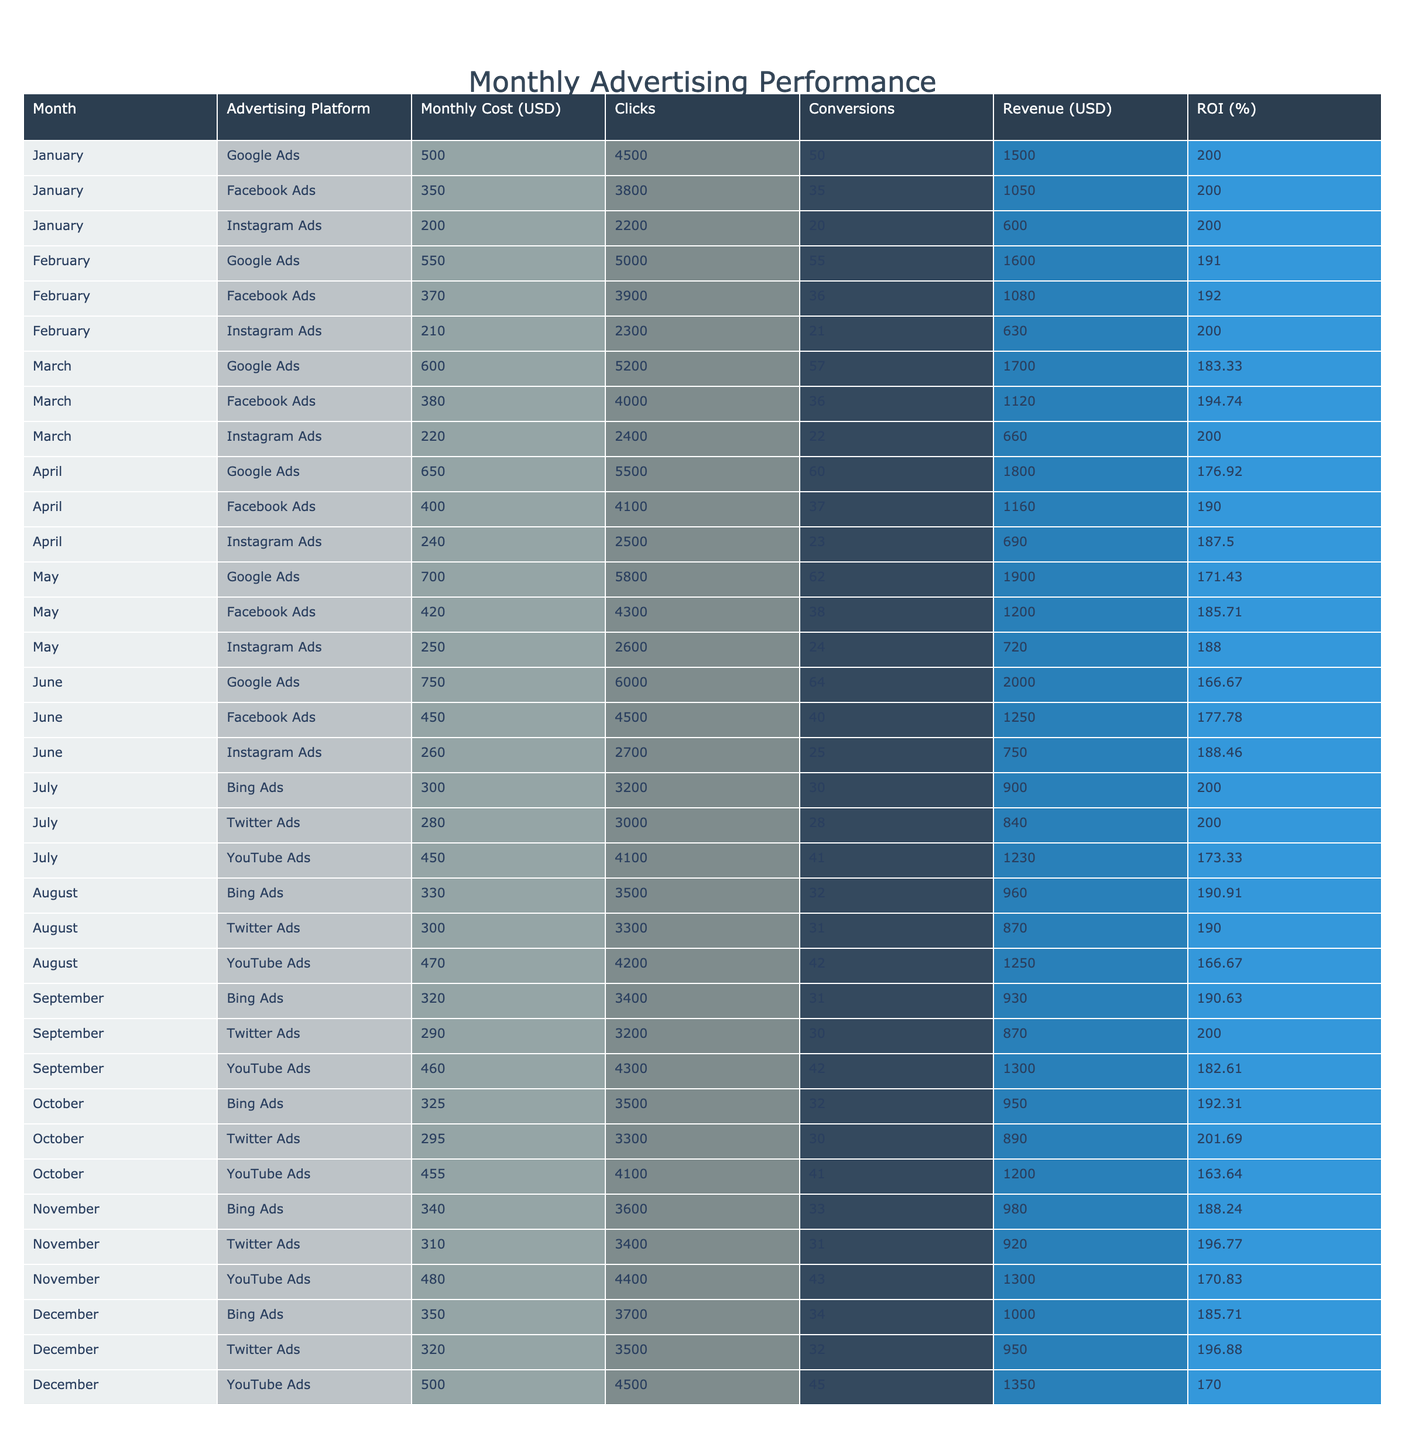What was the highest monthly advertising cost in the table? To find the highest monthly advertising cost, I will review the "Monthly Cost (USD)" column and identify the maximum value. The highest cost is 750.00 USD from Google Ads in June.
Answer: 750.00 USD Which month had the highest ROI for Facebook Ads? I will look for the row corresponding to Facebook Ads and check the "ROI (%)" values. The highest ROI for Facebook Ads is 201.69% in October.
Answer: October What is the total revenue generated from Instagram Ads across all months? I will sum all the values in the "Revenue (USD)" column specifically for Instagram Ads. The total revenue is 600.00 + 630.00 + 660.00 + 690.00 + 720.00 + 750.00 + 960.00 + 870.00 + 950.00 + 980.00 + 1000.00 + 1350.00 = 10,140.00 USD.
Answer: 10,140.00 USD Did Bing Ads achieve an ROI of at least 200% in any month? I will look at the "ROI (%)" values for Bing Ads. The ROI meets or exceeds 200% in January and July. Therefore, the answer is yes.
Answer: Yes What is the average monthly cost of advertising for Twitter Ads? I will collect all the monthly costs for Twitter Ads, which are 280.00, 300.00, 290.00, 310.00, and 320.00 USD. Then, I will calculate the average: (280 + 300 + 290 + 310 + 320) / 5 = 300.00 USD.
Answer: 300.00 USD Which advertising platform had the most conversions in total over the entire year? I will sum the "Conversions" column for each advertising platform and identify the highest total. Google Ads has the highest total conversions of 336, while Facebook Ads has 317, Instagram Ads has 288, Bing Ads has 163, Twitter Ads has 153, and YouTube Ads has 217.
Answer: Google Ads What month yielded the least revenue from advertising overall? I will total the revenue for each month and compare the totals. January has a total revenue of 4170.00, February of 4310.00, March of 3480.00, April of 3660.00, May of 3840.00, June of 4000.00, July of 2970.00, August of 2810.00, September of 3000.00, October of 3030.00, November of 2900.00, and December of 3300.00. July yielded the least revenue overall.
Answer: July Was the monthly advertising cost for YouTube Ads in December lower than in September? I will compare the monthly costs for YouTube Ads in both months. In December, it was 500.00, and in September, it was 460.00. Since 500.00 is greater than 460.00, the statement is false.
Answer: No 